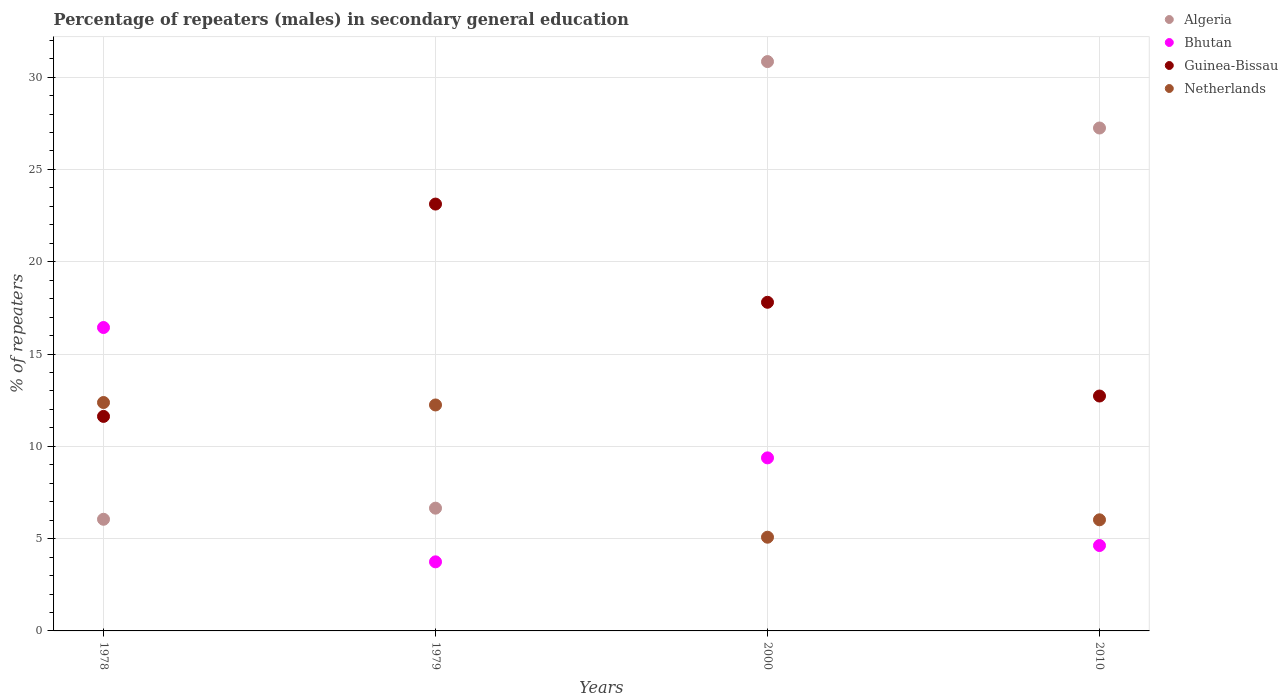How many different coloured dotlines are there?
Offer a terse response. 4. Is the number of dotlines equal to the number of legend labels?
Your answer should be very brief. Yes. What is the percentage of male repeaters in Netherlands in 2010?
Provide a short and direct response. 6.02. Across all years, what is the maximum percentage of male repeaters in Guinea-Bissau?
Provide a short and direct response. 23.12. Across all years, what is the minimum percentage of male repeaters in Bhutan?
Offer a terse response. 3.74. In which year was the percentage of male repeaters in Netherlands maximum?
Ensure brevity in your answer.  1978. In which year was the percentage of male repeaters in Algeria minimum?
Offer a terse response. 1978. What is the total percentage of male repeaters in Guinea-Bissau in the graph?
Provide a short and direct response. 65.27. What is the difference between the percentage of male repeaters in Guinea-Bissau in 1978 and that in 2010?
Make the answer very short. -1.1. What is the difference between the percentage of male repeaters in Bhutan in 1979 and the percentage of male repeaters in Guinea-Bissau in 2000?
Your answer should be compact. -14.06. What is the average percentage of male repeaters in Netherlands per year?
Give a very brief answer. 8.93. In the year 2010, what is the difference between the percentage of male repeaters in Algeria and percentage of male repeaters in Netherlands?
Your response must be concise. 21.23. What is the ratio of the percentage of male repeaters in Netherlands in 1979 to that in 2000?
Your answer should be very brief. 2.41. Is the difference between the percentage of male repeaters in Algeria in 2000 and 2010 greater than the difference between the percentage of male repeaters in Netherlands in 2000 and 2010?
Keep it short and to the point. Yes. What is the difference between the highest and the second highest percentage of male repeaters in Bhutan?
Your answer should be very brief. 7.06. What is the difference between the highest and the lowest percentage of male repeaters in Bhutan?
Give a very brief answer. 12.69. In how many years, is the percentage of male repeaters in Netherlands greater than the average percentage of male repeaters in Netherlands taken over all years?
Make the answer very short. 2. Is it the case that in every year, the sum of the percentage of male repeaters in Netherlands and percentage of male repeaters in Guinea-Bissau  is greater than the percentage of male repeaters in Bhutan?
Make the answer very short. Yes. Is the percentage of male repeaters in Bhutan strictly less than the percentage of male repeaters in Netherlands over the years?
Give a very brief answer. No. How many years are there in the graph?
Offer a terse response. 4. Does the graph contain grids?
Make the answer very short. Yes. Where does the legend appear in the graph?
Your answer should be compact. Top right. How many legend labels are there?
Provide a short and direct response. 4. How are the legend labels stacked?
Provide a short and direct response. Vertical. What is the title of the graph?
Give a very brief answer. Percentage of repeaters (males) in secondary general education. Does "Uzbekistan" appear as one of the legend labels in the graph?
Your answer should be very brief. No. What is the label or title of the X-axis?
Offer a very short reply. Years. What is the label or title of the Y-axis?
Give a very brief answer. % of repeaters. What is the % of repeaters in Algeria in 1978?
Give a very brief answer. 6.05. What is the % of repeaters in Bhutan in 1978?
Provide a succinct answer. 16.44. What is the % of repeaters in Guinea-Bissau in 1978?
Provide a succinct answer. 11.62. What is the % of repeaters in Netherlands in 1978?
Ensure brevity in your answer.  12.37. What is the % of repeaters of Algeria in 1979?
Provide a succinct answer. 6.65. What is the % of repeaters in Bhutan in 1979?
Provide a short and direct response. 3.74. What is the % of repeaters of Guinea-Bissau in 1979?
Provide a succinct answer. 23.12. What is the % of repeaters of Netherlands in 1979?
Your answer should be very brief. 12.24. What is the % of repeaters in Algeria in 2000?
Give a very brief answer. 30.84. What is the % of repeaters of Bhutan in 2000?
Give a very brief answer. 9.37. What is the % of repeaters of Guinea-Bissau in 2000?
Make the answer very short. 17.8. What is the % of repeaters in Netherlands in 2000?
Provide a succinct answer. 5.08. What is the % of repeaters of Algeria in 2010?
Ensure brevity in your answer.  27.24. What is the % of repeaters of Bhutan in 2010?
Make the answer very short. 4.63. What is the % of repeaters of Guinea-Bissau in 2010?
Your answer should be very brief. 12.72. What is the % of repeaters in Netherlands in 2010?
Ensure brevity in your answer.  6.02. Across all years, what is the maximum % of repeaters of Algeria?
Your answer should be very brief. 30.84. Across all years, what is the maximum % of repeaters in Bhutan?
Make the answer very short. 16.44. Across all years, what is the maximum % of repeaters of Guinea-Bissau?
Provide a succinct answer. 23.12. Across all years, what is the maximum % of repeaters of Netherlands?
Your answer should be very brief. 12.37. Across all years, what is the minimum % of repeaters in Algeria?
Provide a short and direct response. 6.05. Across all years, what is the minimum % of repeaters in Bhutan?
Your response must be concise. 3.74. Across all years, what is the minimum % of repeaters of Guinea-Bissau?
Your response must be concise. 11.62. Across all years, what is the minimum % of repeaters in Netherlands?
Give a very brief answer. 5.08. What is the total % of repeaters of Algeria in the graph?
Make the answer very short. 70.78. What is the total % of repeaters in Bhutan in the graph?
Make the answer very short. 34.18. What is the total % of repeaters in Guinea-Bissau in the graph?
Your answer should be compact. 65.27. What is the total % of repeaters in Netherlands in the graph?
Your answer should be compact. 35.71. What is the difference between the % of repeaters of Algeria in 1978 and that in 1979?
Offer a terse response. -0.6. What is the difference between the % of repeaters in Bhutan in 1978 and that in 1979?
Your response must be concise. 12.69. What is the difference between the % of repeaters in Guinea-Bissau in 1978 and that in 1979?
Ensure brevity in your answer.  -11.5. What is the difference between the % of repeaters of Netherlands in 1978 and that in 1979?
Your answer should be very brief. 0.13. What is the difference between the % of repeaters in Algeria in 1978 and that in 2000?
Your answer should be very brief. -24.79. What is the difference between the % of repeaters of Bhutan in 1978 and that in 2000?
Provide a succinct answer. 7.06. What is the difference between the % of repeaters in Guinea-Bissau in 1978 and that in 2000?
Make the answer very short. -6.18. What is the difference between the % of repeaters in Netherlands in 1978 and that in 2000?
Provide a succinct answer. 7.3. What is the difference between the % of repeaters of Algeria in 1978 and that in 2010?
Your answer should be very brief. -21.2. What is the difference between the % of repeaters of Bhutan in 1978 and that in 2010?
Give a very brief answer. 11.81. What is the difference between the % of repeaters of Guinea-Bissau in 1978 and that in 2010?
Offer a terse response. -1.1. What is the difference between the % of repeaters of Netherlands in 1978 and that in 2010?
Provide a short and direct response. 6.35. What is the difference between the % of repeaters of Algeria in 1979 and that in 2000?
Your answer should be compact. -24.19. What is the difference between the % of repeaters in Bhutan in 1979 and that in 2000?
Your response must be concise. -5.63. What is the difference between the % of repeaters of Guinea-Bissau in 1979 and that in 2000?
Provide a succinct answer. 5.32. What is the difference between the % of repeaters in Netherlands in 1979 and that in 2000?
Give a very brief answer. 7.16. What is the difference between the % of repeaters of Algeria in 1979 and that in 2010?
Offer a terse response. -20.59. What is the difference between the % of repeaters in Bhutan in 1979 and that in 2010?
Offer a terse response. -0.88. What is the difference between the % of repeaters in Guinea-Bissau in 1979 and that in 2010?
Offer a very short reply. 10.4. What is the difference between the % of repeaters of Netherlands in 1979 and that in 2010?
Your response must be concise. 6.22. What is the difference between the % of repeaters in Algeria in 2000 and that in 2010?
Ensure brevity in your answer.  3.6. What is the difference between the % of repeaters of Bhutan in 2000 and that in 2010?
Keep it short and to the point. 4.75. What is the difference between the % of repeaters of Guinea-Bissau in 2000 and that in 2010?
Provide a short and direct response. 5.08. What is the difference between the % of repeaters in Netherlands in 2000 and that in 2010?
Provide a short and direct response. -0.94. What is the difference between the % of repeaters in Algeria in 1978 and the % of repeaters in Bhutan in 1979?
Your answer should be compact. 2.31. What is the difference between the % of repeaters in Algeria in 1978 and the % of repeaters in Guinea-Bissau in 1979?
Give a very brief answer. -17.08. What is the difference between the % of repeaters of Algeria in 1978 and the % of repeaters of Netherlands in 1979?
Give a very brief answer. -6.19. What is the difference between the % of repeaters in Bhutan in 1978 and the % of repeaters in Guinea-Bissau in 1979?
Keep it short and to the point. -6.69. What is the difference between the % of repeaters in Bhutan in 1978 and the % of repeaters in Netherlands in 1979?
Provide a succinct answer. 4.2. What is the difference between the % of repeaters in Guinea-Bissau in 1978 and the % of repeaters in Netherlands in 1979?
Offer a terse response. -0.62. What is the difference between the % of repeaters in Algeria in 1978 and the % of repeaters in Bhutan in 2000?
Your response must be concise. -3.33. What is the difference between the % of repeaters in Algeria in 1978 and the % of repeaters in Guinea-Bissau in 2000?
Give a very brief answer. -11.76. What is the difference between the % of repeaters of Algeria in 1978 and the % of repeaters of Netherlands in 2000?
Offer a terse response. 0.97. What is the difference between the % of repeaters in Bhutan in 1978 and the % of repeaters in Guinea-Bissau in 2000?
Keep it short and to the point. -1.37. What is the difference between the % of repeaters of Bhutan in 1978 and the % of repeaters of Netherlands in 2000?
Your response must be concise. 11.36. What is the difference between the % of repeaters of Guinea-Bissau in 1978 and the % of repeaters of Netherlands in 2000?
Offer a very short reply. 6.54. What is the difference between the % of repeaters of Algeria in 1978 and the % of repeaters of Bhutan in 2010?
Your answer should be compact. 1.42. What is the difference between the % of repeaters of Algeria in 1978 and the % of repeaters of Guinea-Bissau in 2010?
Provide a succinct answer. -6.68. What is the difference between the % of repeaters in Algeria in 1978 and the % of repeaters in Netherlands in 2010?
Ensure brevity in your answer.  0.03. What is the difference between the % of repeaters of Bhutan in 1978 and the % of repeaters of Guinea-Bissau in 2010?
Keep it short and to the point. 3.71. What is the difference between the % of repeaters of Bhutan in 1978 and the % of repeaters of Netherlands in 2010?
Your response must be concise. 10.42. What is the difference between the % of repeaters in Guinea-Bissau in 1978 and the % of repeaters in Netherlands in 2010?
Your answer should be very brief. 5.6. What is the difference between the % of repeaters of Algeria in 1979 and the % of repeaters of Bhutan in 2000?
Your answer should be very brief. -2.72. What is the difference between the % of repeaters in Algeria in 1979 and the % of repeaters in Guinea-Bissau in 2000?
Your answer should be very brief. -11.15. What is the difference between the % of repeaters of Algeria in 1979 and the % of repeaters of Netherlands in 2000?
Offer a terse response. 1.57. What is the difference between the % of repeaters in Bhutan in 1979 and the % of repeaters in Guinea-Bissau in 2000?
Make the answer very short. -14.06. What is the difference between the % of repeaters of Bhutan in 1979 and the % of repeaters of Netherlands in 2000?
Keep it short and to the point. -1.33. What is the difference between the % of repeaters in Guinea-Bissau in 1979 and the % of repeaters in Netherlands in 2000?
Offer a very short reply. 18.05. What is the difference between the % of repeaters in Algeria in 1979 and the % of repeaters in Bhutan in 2010?
Make the answer very short. 2.02. What is the difference between the % of repeaters of Algeria in 1979 and the % of repeaters of Guinea-Bissau in 2010?
Your response must be concise. -6.07. What is the difference between the % of repeaters in Algeria in 1979 and the % of repeaters in Netherlands in 2010?
Give a very brief answer. 0.63. What is the difference between the % of repeaters of Bhutan in 1979 and the % of repeaters of Guinea-Bissau in 2010?
Your answer should be very brief. -8.98. What is the difference between the % of repeaters of Bhutan in 1979 and the % of repeaters of Netherlands in 2010?
Offer a very short reply. -2.28. What is the difference between the % of repeaters of Guinea-Bissau in 1979 and the % of repeaters of Netherlands in 2010?
Give a very brief answer. 17.1. What is the difference between the % of repeaters of Algeria in 2000 and the % of repeaters of Bhutan in 2010?
Your answer should be very brief. 26.22. What is the difference between the % of repeaters in Algeria in 2000 and the % of repeaters in Guinea-Bissau in 2010?
Ensure brevity in your answer.  18.12. What is the difference between the % of repeaters of Algeria in 2000 and the % of repeaters of Netherlands in 2010?
Your answer should be compact. 24.82. What is the difference between the % of repeaters of Bhutan in 2000 and the % of repeaters of Guinea-Bissau in 2010?
Your answer should be very brief. -3.35. What is the difference between the % of repeaters in Bhutan in 2000 and the % of repeaters in Netherlands in 2010?
Offer a very short reply. 3.36. What is the difference between the % of repeaters in Guinea-Bissau in 2000 and the % of repeaters in Netherlands in 2010?
Your response must be concise. 11.78. What is the average % of repeaters in Algeria per year?
Your answer should be compact. 17.7. What is the average % of repeaters of Bhutan per year?
Offer a terse response. 8.54. What is the average % of repeaters in Guinea-Bissau per year?
Give a very brief answer. 16.32. What is the average % of repeaters of Netherlands per year?
Ensure brevity in your answer.  8.93. In the year 1978, what is the difference between the % of repeaters of Algeria and % of repeaters of Bhutan?
Provide a short and direct response. -10.39. In the year 1978, what is the difference between the % of repeaters of Algeria and % of repeaters of Guinea-Bissau?
Offer a terse response. -5.57. In the year 1978, what is the difference between the % of repeaters of Algeria and % of repeaters of Netherlands?
Offer a very short reply. -6.33. In the year 1978, what is the difference between the % of repeaters in Bhutan and % of repeaters in Guinea-Bissau?
Your response must be concise. 4.82. In the year 1978, what is the difference between the % of repeaters in Bhutan and % of repeaters in Netherlands?
Provide a short and direct response. 4.06. In the year 1978, what is the difference between the % of repeaters in Guinea-Bissau and % of repeaters in Netherlands?
Give a very brief answer. -0.75. In the year 1979, what is the difference between the % of repeaters of Algeria and % of repeaters of Bhutan?
Offer a very short reply. 2.91. In the year 1979, what is the difference between the % of repeaters in Algeria and % of repeaters in Guinea-Bissau?
Keep it short and to the point. -16.47. In the year 1979, what is the difference between the % of repeaters in Algeria and % of repeaters in Netherlands?
Offer a very short reply. -5.59. In the year 1979, what is the difference between the % of repeaters in Bhutan and % of repeaters in Guinea-Bissau?
Your answer should be compact. -19.38. In the year 1979, what is the difference between the % of repeaters in Bhutan and % of repeaters in Netherlands?
Your answer should be compact. -8.5. In the year 1979, what is the difference between the % of repeaters in Guinea-Bissau and % of repeaters in Netherlands?
Provide a succinct answer. 10.88. In the year 2000, what is the difference between the % of repeaters of Algeria and % of repeaters of Bhutan?
Ensure brevity in your answer.  21.47. In the year 2000, what is the difference between the % of repeaters of Algeria and % of repeaters of Guinea-Bissau?
Keep it short and to the point. 13.04. In the year 2000, what is the difference between the % of repeaters in Algeria and % of repeaters in Netherlands?
Offer a terse response. 25.77. In the year 2000, what is the difference between the % of repeaters of Bhutan and % of repeaters of Guinea-Bissau?
Ensure brevity in your answer.  -8.43. In the year 2000, what is the difference between the % of repeaters of Bhutan and % of repeaters of Netherlands?
Keep it short and to the point. 4.3. In the year 2000, what is the difference between the % of repeaters in Guinea-Bissau and % of repeaters in Netherlands?
Ensure brevity in your answer.  12.73. In the year 2010, what is the difference between the % of repeaters of Algeria and % of repeaters of Bhutan?
Keep it short and to the point. 22.62. In the year 2010, what is the difference between the % of repeaters in Algeria and % of repeaters in Guinea-Bissau?
Keep it short and to the point. 14.52. In the year 2010, what is the difference between the % of repeaters in Algeria and % of repeaters in Netherlands?
Your answer should be compact. 21.23. In the year 2010, what is the difference between the % of repeaters in Bhutan and % of repeaters in Guinea-Bissau?
Give a very brief answer. -8.1. In the year 2010, what is the difference between the % of repeaters in Bhutan and % of repeaters in Netherlands?
Provide a short and direct response. -1.39. In the year 2010, what is the difference between the % of repeaters of Guinea-Bissau and % of repeaters of Netherlands?
Your answer should be very brief. 6.71. What is the ratio of the % of repeaters in Algeria in 1978 to that in 1979?
Provide a succinct answer. 0.91. What is the ratio of the % of repeaters in Bhutan in 1978 to that in 1979?
Keep it short and to the point. 4.39. What is the ratio of the % of repeaters of Guinea-Bissau in 1978 to that in 1979?
Keep it short and to the point. 0.5. What is the ratio of the % of repeaters of Netherlands in 1978 to that in 1979?
Your response must be concise. 1.01. What is the ratio of the % of repeaters in Algeria in 1978 to that in 2000?
Provide a succinct answer. 0.2. What is the ratio of the % of repeaters in Bhutan in 1978 to that in 2000?
Your response must be concise. 1.75. What is the ratio of the % of repeaters of Guinea-Bissau in 1978 to that in 2000?
Provide a short and direct response. 0.65. What is the ratio of the % of repeaters in Netherlands in 1978 to that in 2000?
Make the answer very short. 2.44. What is the ratio of the % of repeaters of Algeria in 1978 to that in 2010?
Your answer should be compact. 0.22. What is the ratio of the % of repeaters in Bhutan in 1978 to that in 2010?
Provide a succinct answer. 3.55. What is the ratio of the % of repeaters of Guinea-Bissau in 1978 to that in 2010?
Your answer should be very brief. 0.91. What is the ratio of the % of repeaters in Netherlands in 1978 to that in 2010?
Make the answer very short. 2.06. What is the ratio of the % of repeaters of Algeria in 1979 to that in 2000?
Ensure brevity in your answer.  0.22. What is the ratio of the % of repeaters of Bhutan in 1979 to that in 2000?
Your answer should be very brief. 0.4. What is the ratio of the % of repeaters of Guinea-Bissau in 1979 to that in 2000?
Offer a terse response. 1.3. What is the ratio of the % of repeaters in Netherlands in 1979 to that in 2000?
Your response must be concise. 2.41. What is the ratio of the % of repeaters in Algeria in 1979 to that in 2010?
Keep it short and to the point. 0.24. What is the ratio of the % of repeaters of Bhutan in 1979 to that in 2010?
Your answer should be very brief. 0.81. What is the ratio of the % of repeaters in Guinea-Bissau in 1979 to that in 2010?
Provide a succinct answer. 1.82. What is the ratio of the % of repeaters in Netherlands in 1979 to that in 2010?
Make the answer very short. 2.03. What is the ratio of the % of repeaters in Algeria in 2000 to that in 2010?
Offer a very short reply. 1.13. What is the ratio of the % of repeaters of Bhutan in 2000 to that in 2010?
Your answer should be compact. 2.03. What is the ratio of the % of repeaters in Guinea-Bissau in 2000 to that in 2010?
Offer a very short reply. 1.4. What is the ratio of the % of repeaters in Netherlands in 2000 to that in 2010?
Ensure brevity in your answer.  0.84. What is the difference between the highest and the second highest % of repeaters of Algeria?
Offer a terse response. 3.6. What is the difference between the highest and the second highest % of repeaters in Bhutan?
Keep it short and to the point. 7.06. What is the difference between the highest and the second highest % of repeaters of Guinea-Bissau?
Your answer should be very brief. 5.32. What is the difference between the highest and the second highest % of repeaters in Netherlands?
Your answer should be very brief. 0.13. What is the difference between the highest and the lowest % of repeaters in Algeria?
Give a very brief answer. 24.79. What is the difference between the highest and the lowest % of repeaters in Bhutan?
Provide a succinct answer. 12.69. What is the difference between the highest and the lowest % of repeaters of Guinea-Bissau?
Offer a very short reply. 11.5. What is the difference between the highest and the lowest % of repeaters of Netherlands?
Your answer should be very brief. 7.3. 